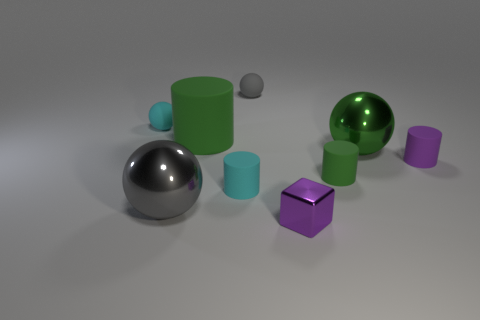How does the light appear to interact with the surfaces of the objects? The light creates highlights and shadows that accentuate the objects' three-dimensional forms. Reflective surfaces have brighter highlights and clearer reflections, while the matte surfaces show more diffused lighting and softer shadows. 